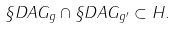<formula> <loc_0><loc_0><loc_500><loc_500>\S D A G _ { g } \cap \S D A G _ { g ^ { \prime } } \subset H .</formula> 